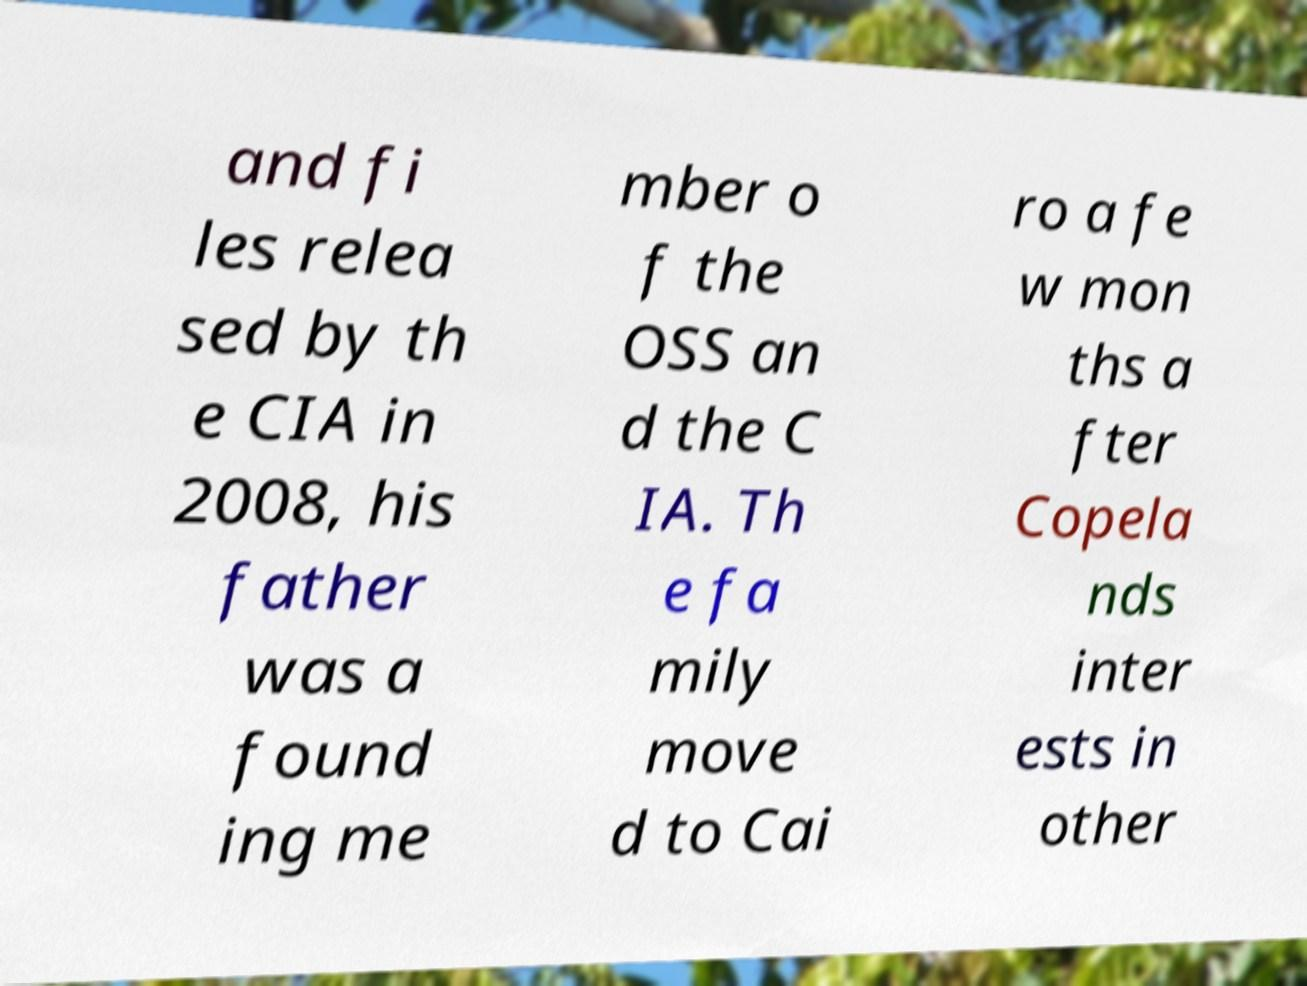Can you read and provide the text displayed in the image?This photo seems to have some interesting text. Can you extract and type it out for me? and fi les relea sed by th e CIA in 2008, his father was a found ing me mber o f the OSS an d the C IA. Th e fa mily move d to Cai ro a fe w mon ths a fter Copela nds inter ests in other 